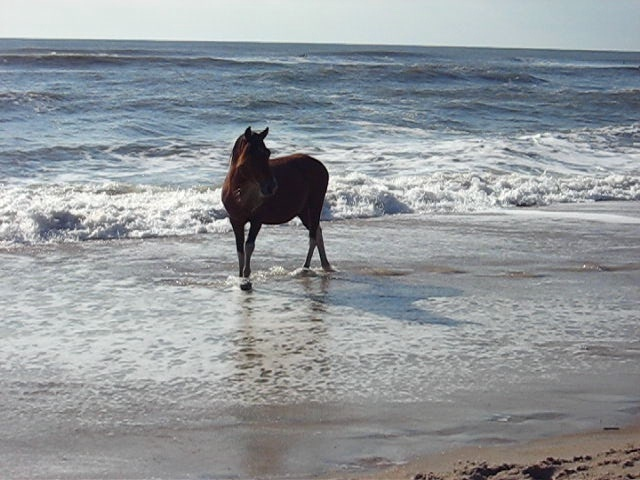Describe the objects in this image and their specific colors. I can see a horse in lightgray, black, gray, darkgray, and maroon tones in this image. 